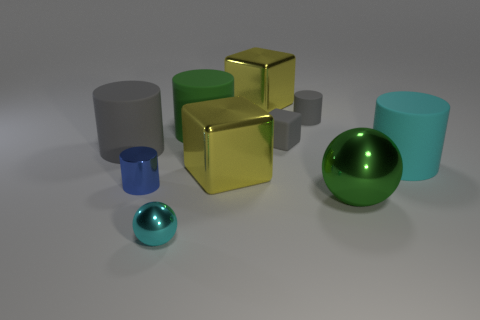Subtract all blue cylinders. How many cylinders are left? 4 Subtract all big cyan matte cylinders. How many cylinders are left? 4 Subtract all red cylinders. Subtract all green cubes. How many cylinders are left? 5 Subtract all cubes. How many objects are left? 7 Subtract 1 cyan cylinders. How many objects are left? 9 Subtract all large metal objects. Subtract all gray rubber cylinders. How many objects are left? 5 Add 9 small cyan metallic spheres. How many small cyan metallic spheres are left? 10 Add 2 large cylinders. How many large cylinders exist? 5 